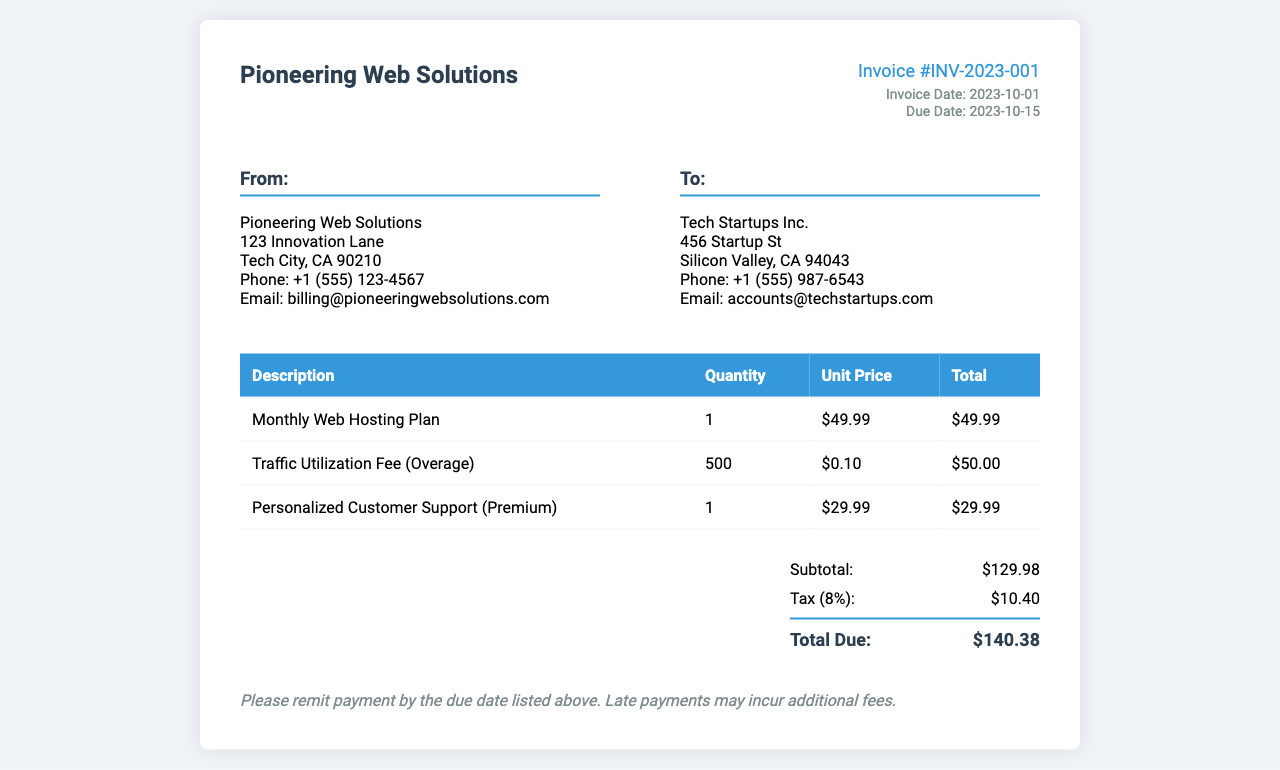What is the invoice number? The invoice number is prominently displayed at the top right of the document as "Invoice #INV-2023-001."
Answer: Invoice #INV-2023-001 What is the total due amount? The total due is calculated at the end of the invoice based on the subtotal and tax, which is "$140.38."
Answer: $140.38 What is the invoice date? The invoice date is mentioned in the invoice details section, specified as "2023-10-01."
Answer: 2023-10-01 What is the unit price for the Monthly Web Hosting Plan? The unit price for the Monthly Web Hosting Plan is listed in the services table as "$49.99."
Answer: $49.99 What is the traffic utilization fee per unit? The traffic utilization fee per unit is included in the services table and is "$0.10."
Answer: $0.10 How much is charged for personalized customer support? The charge for personalized customer support is provided in the services table as "$29.99."
Answer: $29.99 What is the tax percentage applied to the invoice? The tax percentage applied is mentioned in the summary section as "8%."
Answer: 8% What is the address of the service provider? The address of the service provider is listed in the "From:" section as "123 Innovation Lane, Tech City, CA 90210."
Answer: 123 Innovation Lane, Tech City, CA 90210 When is the payment due date? The payment due date is specified under the invoice details as "2023-10-15."
Answer: 2023-10-15 